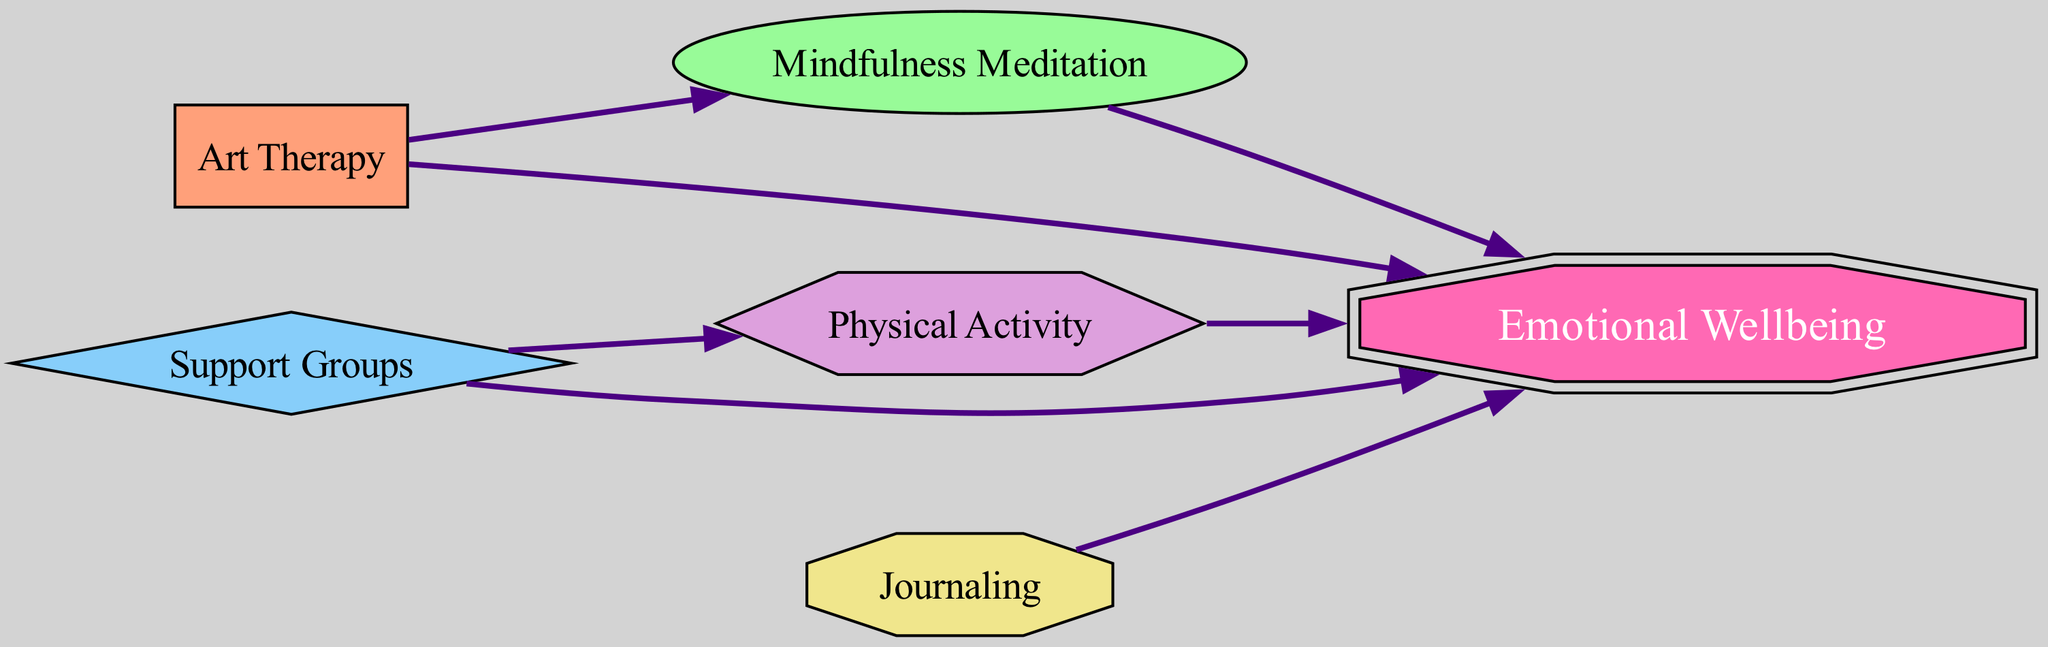How many nodes are in the diagram? The diagram has a total of six nodes: Art Therapy, Mindfulness Meditation, Support Groups, Physical Activity, Journaling, and Emotional Wellbeing.
Answer: 6 What is the relationship between Support Groups and Emotional Wellbeing? In the diagram, there is a directed edge from Support Groups to Emotional Wellbeing, indicating that Support Groups contribute positively to Emotional Wellbeing.
Answer: Contributes positively Which coping strategy has a direct path to Mindfulness Meditation? The diagram shows a directed edge from Art Therapy to Mindfulness Meditation, indicating that Art Therapy has a direct influence on Mindfulness Meditation.
Answer: Art Therapy How many edges connect to Emotional Wellbeing? There are five edges that lead to Emotional Wellbeing from various coping strategies: Art Therapy, Mindfulness Meditation, Support Groups, Physical Activity, and Journaling.
Answer: 5 Which strategy connects both to Physical Activity and Emotional Wellbeing? The node Support Groups has a direct edge to Physical Activity and another edge leading to Emotional Wellbeing, indicating its connection to both.
Answer: Support Groups What shape represents Journaling in the diagram? Journaling is represented by an octagon in the diagram, which is a unique shape distinguishing it from other node types.
Answer: Octagon Which coping strategies directly influence Emotional Wellbeing? The coping strategies that directly influence Emotional Wellbeing are Art Therapy, Mindfulness Meditation, Support Groups, Physical Activity, and Journaling, as indicated by the directed edges.
Answer: Art Therapy, Mindfulness Meditation, Support Groups, Physical Activity, Journaling What is the main output node in the diagram? The main output node indicating the ultimate goal for all the coping strategies in this diagram is Emotional Wellbeing, as all strategies point toward it.
Answer: Emotional Wellbeing Is there a connection between Art Therapy and Physical Activity? There is no direct edge connecting Art Therapy to Physical Activity in the diagram, meaning Art Therapy does not influence Physical Activity directly.
Answer: No 